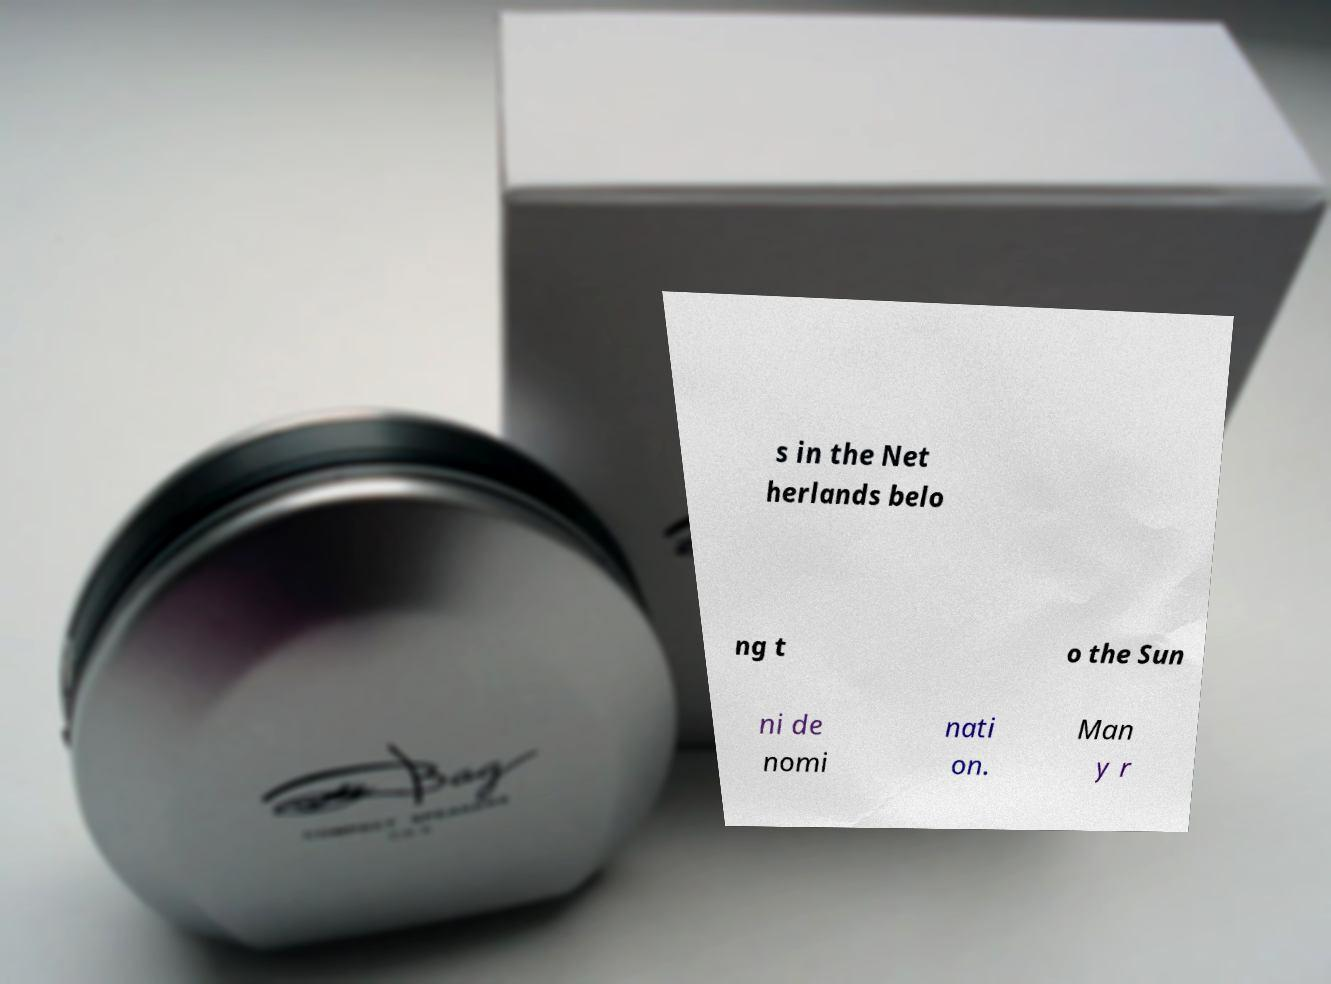Can you read and provide the text displayed in the image?This photo seems to have some interesting text. Can you extract and type it out for me? s in the Net herlands belo ng t o the Sun ni de nomi nati on. Man y r 